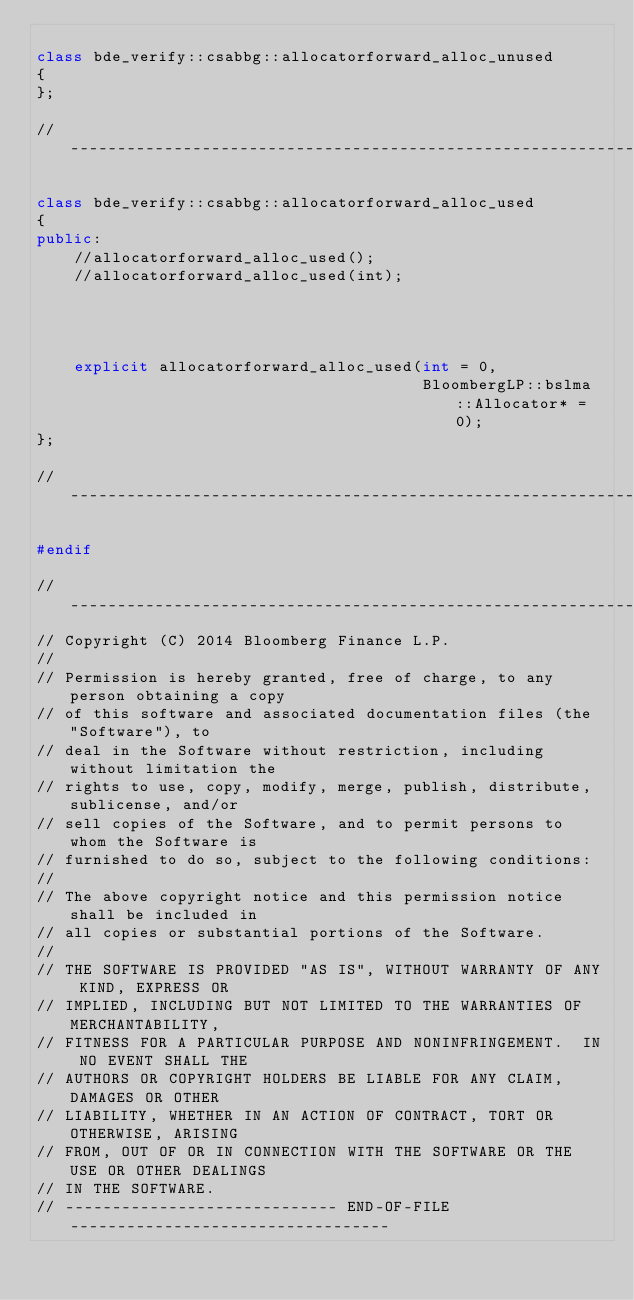Convert code to text. <code><loc_0><loc_0><loc_500><loc_500><_C++_>
class bde_verify::csabbg::allocatorforward_alloc_unused
{
};

// -----------------------------------------------------------------------------

class bde_verify::csabbg::allocatorforward_alloc_used
{
public:
    //allocatorforward_alloc_used();
    //allocatorforward_alloc_used(int);
                                                                    // IMPLICIT
    explicit allocatorforward_alloc_used(int = 0,
                                         BloombergLP::bslma::Allocator* = 0);
};

// -----------------------------------------------------------------------------

#endif

// ----------------------------------------------------------------------------
// Copyright (C) 2014 Bloomberg Finance L.P.
//
// Permission is hereby granted, free of charge, to any person obtaining a copy
// of this software and associated documentation files (the "Software"), to
// deal in the Software without restriction, including without limitation the
// rights to use, copy, modify, merge, publish, distribute, sublicense, and/or
// sell copies of the Software, and to permit persons to whom the Software is
// furnished to do so, subject to the following conditions:
//
// The above copyright notice and this permission notice shall be included in
// all copies or substantial portions of the Software.
//
// THE SOFTWARE IS PROVIDED "AS IS", WITHOUT WARRANTY OF ANY KIND, EXPRESS OR
// IMPLIED, INCLUDING BUT NOT LIMITED TO THE WARRANTIES OF MERCHANTABILITY,
// FITNESS FOR A PARTICULAR PURPOSE AND NONINFRINGEMENT.  IN NO EVENT SHALL THE
// AUTHORS OR COPYRIGHT HOLDERS BE LIABLE FOR ANY CLAIM, DAMAGES OR OTHER
// LIABILITY, WHETHER IN AN ACTION OF CONTRACT, TORT OR OTHERWISE, ARISING
// FROM, OUT OF OR IN CONNECTION WITH THE SOFTWARE OR THE USE OR OTHER DEALINGS
// IN THE SOFTWARE.
// ----------------------------- END-OF-FILE ----------------------------------
</code> 